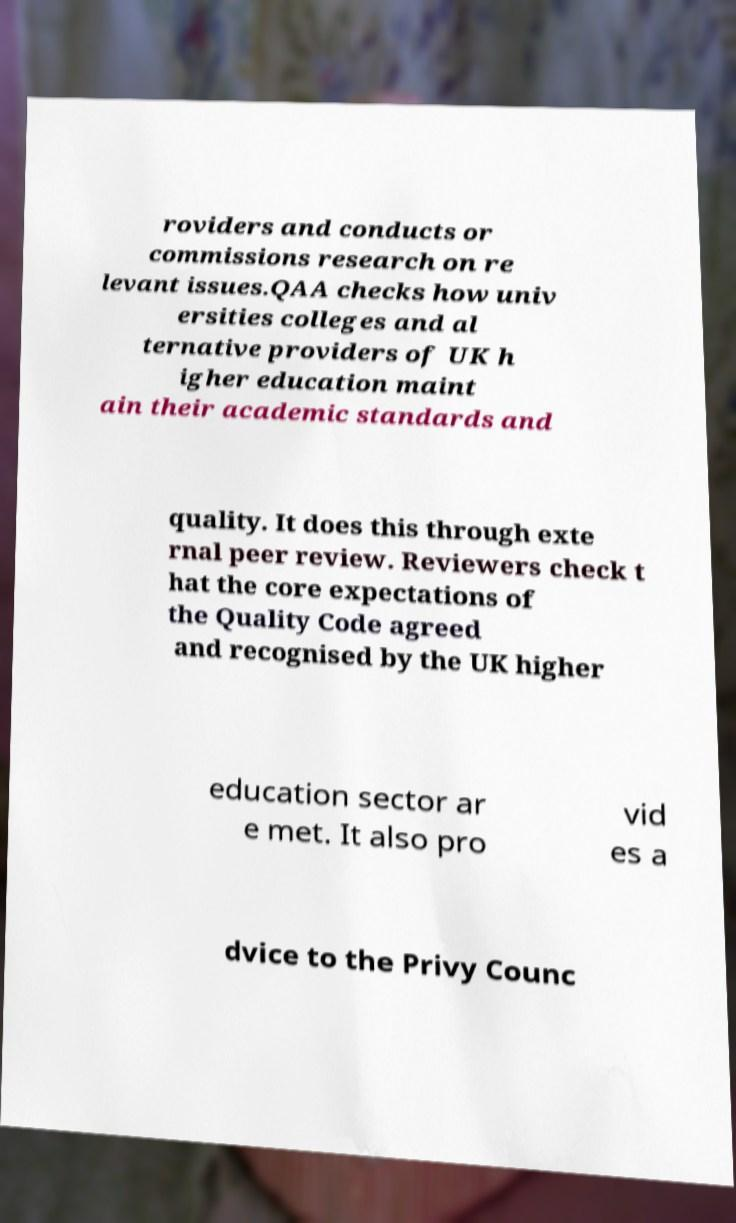Could you assist in decoding the text presented in this image and type it out clearly? roviders and conducts or commissions research on re levant issues.QAA checks how univ ersities colleges and al ternative providers of UK h igher education maint ain their academic standards and quality. It does this through exte rnal peer review. Reviewers check t hat the core expectations of the Quality Code agreed and recognised by the UK higher education sector ar e met. It also pro vid es a dvice to the Privy Counc 